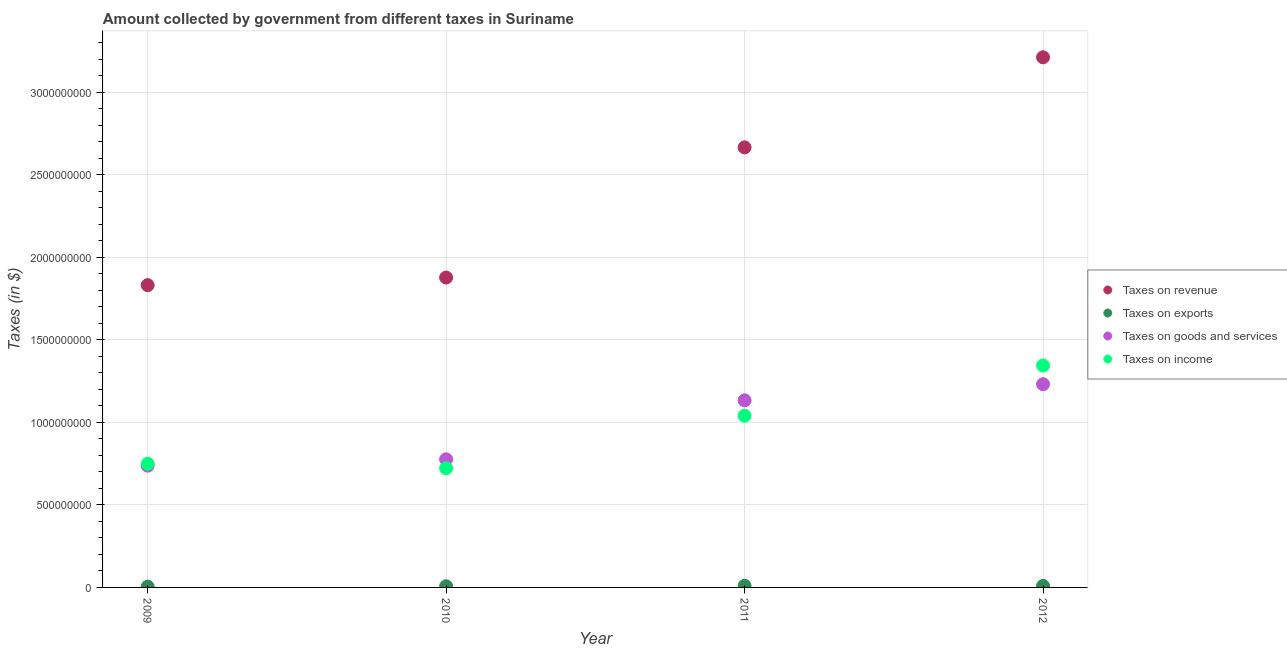What is the amount collected as tax on goods in 2009?
Give a very brief answer. 7.38e+08. Across all years, what is the maximum amount collected as tax on income?
Provide a short and direct response. 1.34e+09. Across all years, what is the minimum amount collected as tax on exports?
Provide a short and direct response. 4.27e+06. What is the total amount collected as tax on income in the graph?
Provide a succinct answer. 3.86e+09. What is the difference between the amount collected as tax on goods in 2009 and that in 2011?
Your answer should be compact. -3.96e+08. What is the difference between the amount collected as tax on goods in 2011 and the amount collected as tax on income in 2012?
Your response must be concise. -2.11e+08. What is the average amount collected as tax on revenue per year?
Your response must be concise. 2.40e+09. In the year 2012, what is the difference between the amount collected as tax on income and amount collected as tax on revenue?
Your answer should be compact. -1.87e+09. What is the ratio of the amount collected as tax on goods in 2009 to that in 2010?
Offer a very short reply. 0.95. Is the difference between the amount collected as tax on goods in 2011 and 2012 greater than the difference between the amount collected as tax on revenue in 2011 and 2012?
Provide a short and direct response. Yes. What is the difference between the highest and the second highest amount collected as tax on income?
Provide a succinct answer. 3.04e+08. What is the difference between the highest and the lowest amount collected as tax on income?
Ensure brevity in your answer.  6.23e+08. In how many years, is the amount collected as tax on income greater than the average amount collected as tax on income taken over all years?
Make the answer very short. 2. Is the sum of the amount collected as tax on revenue in 2010 and 2011 greater than the maximum amount collected as tax on income across all years?
Make the answer very short. Yes. Is it the case that in every year, the sum of the amount collected as tax on revenue and amount collected as tax on exports is greater than the sum of amount collected as tax on goods and amount collected as tax on income?
Your response must be concise. No. Is it the case that in every year, the sum of the amount collected as tax on revenue and amount collected as tax on exports is greater than the amount collected as tax on goods?
Your answer should be very brief. Yes. Does the amount collected as tax on goods monotonically increase over the years?
Provide a succinct answer. Yes. Is the amount collected as tax on income strictly greater than the amount collected as tax on goods over the years?
Ensure brevity in your answer.  No. How many dotlines are there?
Give a very brief answer. 4. How many years are there in the graph?
Keep it short and to the point. 4. What is the difference between two consecutive major ticks on the Y-axis?
Provide a succinct answer. 5.00e+08. Does the graph contain any zero values?
Your answer should be compact. No. Does the graph contain grids?
Your response must be concise. Yes. How are the legend labels stacked?
Keep it short and to the point. Vertical. What is the title of the graph?
Your response must be concise. Amount collected by government from different taxes in Suriname. Does "Finland" appear as one of the legend labels in the graph?
Your response must be concise. No. What is the label or title of the X-axis?
Provide a short and direct response. Year. What is the label or title of the Y-axis?
Provide a succinct answer. Taxes (in $). What is the Taxes (in $) in Taxes on revenue in 2009?
Offer a terse response. 1.83e+09. What is the Taxes (in $) of Taxes on exports in 2009?
Ensure brevity in your answer.  4.27e+06. What is the Taxes (in $) in Taxes on goods and services in 2009?
Offer a terse response. 7.38e+08. What is the Taxes (in $) of Taxes on income in 2009?
Ensure brevity in your answer.  7.49e+08. What is the Taxes (in $) of Taxes on revenue in 2010?
Your answer should be compact. 1.88e+09. What is the Taxes (in $) in Taxes on exports in 2010?
Keep it short and to the point. 7.16e+06. What is the Taxes (in $) in Taxes on goods and services in 2010?
Provide a succinct answer. 7.76e+08. What is the Taxes (in $) of Taxes on income in 2010?
Give a very brief answer. 7.22e+08. What is the Taxes (in $) in Taxes on revenue in 2011?
Provide a short and direct response. 2.67e+09. What is the Taxes (in $) in Taxes on exports in 2011?
Your answer should be very brief. 9.93e+06. What is the Taxes (in $) in Taxes on goods and services in 2011?
Your response must be concise. 1.13e+09. What is the Taxes (in $) in Taxes on income in 2011?
Ensure brevity in your answer.  1.04e+09. What is the Taxes (in $) of Taxes on revenue in 2012?
Keep it short and to the point. 3.21e+09. What is the Taxes (in $) in Taxes on exports in 2012?
Make the answer very short. 9.10e+06. What is the Taxes (in $) of Taxes on goods and services in 2012?
Ensure brevity in your answer.  1.23e+09. What is the Taxes (in $) of Taxes on income in 2012?
Provide a succinct answer. 1.34e+09. Across all years, what is the maximum Taxes (in $) in Taxes on revenue?
Ensure brevity in your answer.  3.21e+09. Across all years, what is the maximum Taxes (in $) of Taxes on exports?
Provide a short and direct response. 9.93e+06. Across all years, what is the maximum Taxes (in $) in Taxes on goods and services?
Offer a very short reply. 1.23e+09. Across all years, what is the maximum Taxes (in $) in Taxes on income?
Your response must be concise. 1.34e+09. Across all years, what is the minimum Taxes (in $) in Taxes on revenue?
Offer a very short reply. 1.83e+09. Across all years, what is the minimum Taxes (in $) in Taxes on exports?
Your response must be concise. 4.27e+06. Across all years, what is the minimum Taxes (in $) in Taxes on goods and services?
Give a very brief answer. 7.38e+08. Across all years, what is the minimum Taxes (in $) of Taxes on income?
Keep it short and to the point. 7.22e+08. What is the total Taxes (in $) of Taxes on revenue in the graph?
Make the answer very short. 9.59e+09. What is the total Taxes (in $) of Taxes on exports in the graph?
Make the answer very short. 3.05e+07. What is the total Taxes (in $) in Taxes on goods and services in the graph?
Provide a succinct answer. 3.88e+09. What is the total Taxes (in $) in Taxes on income in the graph?
Give a very brief answer. 3.86e+09. What is the difference between the Taxes (in $) in Taxes on revenue in 2009 and that in 2010?
Your answer should be very brief. -4.60e+07. What is the difference between the Taxes (in $) of Taxes on exports in 2009 and that in 2010?
Offer a very short reply. -2.89e+06. What is the difference between the Taxes (in $) in Taxes on goods and services in 2009 and that in 2010?
Provide a succinct answer. -3.87e+07. What is the difference between the Taxes (in $) of Taxes on income in 2009 and that in 2010?
Make the answer very short. 2.70e+07. What is the difference between the Taxes (in $) of Taxes on revenue in 2009 and that in 2011?
Give a very brief answer. -8.35e+08. What is the difference between the Taxes (in $) of Taxes on exports in 2009 and that in 2011?
Make the answer very short. -5.66e+06. What is the difference between the Taxes (in $) of Taxes on goods and services in 2009 and that in 2011?
Keep it short and to the point. -3.96e+08. What is the difference between the Taxes (in $) of Taxes on income in 2009 and that in 2011?
Offer a very short reply. -2.91e+08. What is the difference between the Taxes (in $) in Taxes on revenue in 2009 and that in 2012?
Provide a short and direct response. -1.38e+09. What is the difference between the Taxes (in $) in Taxes on exports in 2009 and that in 2012?
Offer a very short reply. -4.83e+06. What is the difference between the Taxes (in $) in Taxes on goods and services in 2009 and that in 2012?
Keep it short and to the point. -4.94e+08. What is the difference between the Taxes (in $) in Taxes on income in 2009 and that in 2012?
Your response must be concise. -5.95e+08. What is the difference between the Taxes (in $) in Taxes on revenue in 2010 and that in 2011?
Ensure brevity in your answer.  -7.89e+08. What is the difference between the Taxes (in $) in Taxes on exports in 2010 and that in 2011?
Ensure brevity in your answer.  -2.77e+06. What is the difference between the Taxes (in $) of Taxes on goods and services in 2010 and that in 2011?
Provide a succinct answer. -3.57e+08. What is the difference between the Taxes (in $) of Taxes on income in 2010 and that in 2011?
Your answer should be very brief. -3.18e+08. What is the difference between the Taxes (in $) in Taxes on revenue in 2010 and that in 2012?
Offer a terse response. -1.33e+09. What is the difference between the Taxes (in $) of Taxes on exports in 2010 and that in 2012?
Your answer should be compact. -1.94e+06. What is the difference between the Taxes (in $) of Taxes on goods and services in 2010 and that in 2012?
Make the answer very short. -4.55e+08. What is the difference between the Taxes (in $) of Taxes on income in 2010 and that in 2012?
Provide a succinct answer. -6.23e+08. What is the difference between the Taxes (in $) in Taxes on revenue in 2011 and that in 2012?
Keep it short and to the point. -5.46e+08. What is the difference between the Taxes (in $) of Taxes on exports in 2011 and that in 2012?
Your answer should be compact. 8.28e+05. What is the difference between the Taxes (in $) in Taxes on goods and services in 2011 and that in 2012?
Your response must be concise. -9.76e+07. What is the difference between the Taxes (in $) of Taxes on income in 2011 and that in 2012?
Make the answer very short. -3.04e+08. What is the difference between the Taxes (in $) in Taxes on revenue in 2009 and the Taxes (in $) in Taxes on exports in 2010?
Provide a succinct answer. 1.82e+09. What is the difference between the Taxes (in $) of Taxes on revenue in 2009 and the Taxes (in $) of Taxes on goods and services in 2010?
Make the answer very short. 1.06e+09. What is the difference between the Taxes (in $) in Taxes on revenue in 2009 and the Taxes (in $) in Taxes on income in 2010?
Keep it short and to the point. 1.11e+09. What is the difference between the Taxes (in $) in Taxes on exports in 2009 and the Taxes (in $) in Taxes on goods and services in 2010?
Make the answer very short. -7.72e+08. What is the difference between the Taxes (in $) of Taxes on exports in 2009 and the Taxes (in $) of Taxes on income in 2010?
Keep it short and to the point. -7.18e+08. What is the difference between the Taxes (in $) of Taxes on goods and services in 2009 and the Taxes (in $) of Taxes on income in 2010?
Your answer should be compact. 1.53e+07. What is the difference between the Taxes (in $) in Taxes on revenue in 2009 and the Taxes (in $) in Taxes on exports in 2011?
Offer a terse response. 1.82e+09. What is the difference between the Taxes (in $) in Taxes on revenue in 2009 and the Taxes (in $) in Taxes on goods and services in 2011?
Offer a very short reply. 6.98e+08. What is the difference between the Taxes (in $) of Taxes on revenue in 2009 and the Taxes (in $) of Taxes on income in 2011?
Ensure brevity in your answer.  7.91e+08. What is the difference between the Taxes (in $) in Taxes on exports in 2009 and the Taxes (in $) in Taxes on goods and services in 2011?
Provide a succinct answer. -1.13e+09. What is the difference between the Taxes (in $) of Taxes on exports in 2009 and the Taxes (in $) of Taxes on income in 2011?
Ensure brevity in your answer.  -1.04e+09. What is the difference between the Taxes (in $) in Taxes on goods and services in 2009 and the Taxes (in $) in Taxes on income in 2011?
Provide a succinct answer. -3.03e+08. What is the difference between the Taxes (in $) in Taxes on revenue in 2009 and the Taxes (in $) in Taxes on exports in 2012?
Provide a succinct answer. 1.82e+09. What is the difference between the Taxes (in $) of Taxes on revenue in 2009 and the Taxes (in $) of Taxes on goods and services in 2012?
Your answer should be compact. 6.00e+08. What is the difference between the Taxes (in $) in Taxes on revenue in 2009 and the Taxes (in $) in Taxes on income in 2012?
Your answer should be very brief. 4.87e+08. What is the difference between the Taxes (in $) in Taxes on exports in 2009 and the Taxes (in $) in Taxes on goods and services in 2012?
Make the answer very short. -1.23e+09. What is the difference between the Taxes (in $) in Taxes on exports in 2009 and the Taxes (in $) in Taxes on income in 2012?
Provide a short and direct response. -1.34e+09. What is the difference between the Taxes (in $) in Taxes on goods and services in 2009 and the Taxes (in $) in Taxes on income in 2012?
Provide a succinct answer. -6.07e+08. What is the difference between the Taxes (in $) of Taxes on revenue in 2010 and the Taxes (in $) of Taxes on exports in 2011?
Provide a short and direct response. 1.87e+09. What is the difference between the Taxes (in $) in Taxes on revenue in 2010 and the Taxes (in $) in Taxes on goods and services in 2011?
Give a very brief answer. 7.44e+08. What is the difference between the Taxes (in $) of Taxes on revenue in 2010 and the Taxes (in $) of Taxes on income in 2011?
Ensure brevity in your answer.  8.37e+08. What is the difference between the Taxes (in $) in Taxes on exports in 2010 and the Taxes (in $) in Taxes on goods and services in 2011?
Make the answer very short. -1.13e+09. What is the difference between the Taxes (in $) in Taxes on exports in 2010 and the Taxes (in $) in Taxes on income in 2011?
Ensure brevity in your answer.  -1.03e+09. What is the difference between the Taxes (in $) of Taxes on goods and services in 2010 and the Taxes (in $) of Taxes on income in 2011?
Keep it short and to the point. -2.64e+08. What is the difference between the Taxes (in $) in Taxes on revenue in 2010 and the Taxes (in $) in Taxes on exports in 2012?
Ensure brevity in your answer.  1.87e+09. What is the difference between the Taxes (in $) of Taxes on revenue in 2010 and the Taxes (in $) of Taxes on goods and services in 2012?
Give a very brief answer. 6.46e+08. What is the difference between the Taxes (in $) in Taxes on revenue in 2010 and the Taxes (in $) in Taxes on income in 2012?
Provide a short and direct response. 5.33e+08. What is the difference between the Taxes (in $) of Taxes on exports in 2010 and the Taxes (in $) of Taxes on goods and services in 2012?
Provide a succinct answer. -1.22e+09. What is the difference between the Taxes (in $) of Taxes on exports in 2010 and the Taxes (in $) of Taxes on income in 2012?
Offer a terse response. -1.34e+09. What is the difference between the Taxes (in $) in Taxes on goods and services in 2010 and the Taxes (in $) in Taxes on income in 2012?
Offer a terse response. -5.68e+08. What is the difference between the Taxes (in $) of Taxes on revenue in 2011 and the Taxes (in $) of Taxes on exports in 2012?
Keep it short and to the point. 2.66e+09. What is the difference between the Taxes (in $) in Taxes on revenue in 2011 and the Taxes (in $) in Taxes on goods and services in 2012?
Your answer should be very brief. 1.44e+09. What is the difference between the Taxes (in $) of Taxes on revenue in 2011 and the Taxes (in $) of Taxes on income in 2012?
Offer a very short reply. 1.32e+09. What is the difference between the Taxes (in $) in Taxes on exports in 2011 and the Taxes (in $) in Taxes on goods and services in 2012?
Your answer should be compact. -1.22e+09. What is the difference between the Taxes (in $) in Taxes on exports in 2011 and the Taxes (in $) in Taxes on income in 2012?
Make the answer very short. -1.33e+09. What is the difference between the Taxes (in $) of Taxes on goods and services in 2011 and the Taxes (in $) of Taxes on income in 2012?
Offer a terse response. -2.11e+08. What is the average Taxes (in $) in Taxes on revenue per year?
Offer a terse response. 2.40e+09. What is the average Taxes (in $) in Taxes on exports per year?
Your answer should be compact. 7.62e+06. What is the average Taxes (in $) in Taxes on goods and services per year?
Keep it short and to the point. 9.70e+08. What is the average Taxes (in $) of Taxes on income per year?
Offer a terse response. 9.64e+08. In the year 2009, what is the difference between the Taxes (in $) in Taxes on revenue and Taxes (in $) in Taxes on exports?
Provide a short and direct response. 1.83e+09. In the year 2009, what is the difference between the Taxes (in $) of Taxes on revenue and Taxes (in $) of Taxes on goods and services?
Ensure brevity in your answer.  1.09e+09. In the year 2009, what is the difference between the Taxes (in $) of Taxes on revenue and Taxes (in $) of Taxes on income?
Keep it short and to the point. 1.08e+09. In the year 2009, what is the difference between the Taxes (in $) of Taxes on exports and Taxes (in $) of Taxes on goods and services?
Ensure brevity in your answer.  -7.33e+08. In the year 2009, what is the difference between the Taxes (in $) of Taxes on exports and Taxes (in $) of Taxes on income?
Provide a succinct answer. -7.45e+08. In the year 2009, what is the difference between the Taxes (in $) of Taxes on goods and services and Taxes (in $) of Taxes on income?
Make the answer very short. -1.17e+07. In the year 2010, what is the difference between the Taxes (in $) of Taxes on revenue and Taxes (in $) of Taxes on exports?
Provide a short and direct response. 1.87e+09. In the year 2010, what is the difference between the Taxes (in $) of Taxes on revenue and Taxes (in $) of Taxes on goods and services?
Your answer should be very brief. 1.10e+09. In the year 2010, what is the difference between the Taxes (in $) in Taxes on revenue and Taxes (in $) in Taxes on income?
Give a very brief answer. 1.16e+09. In the year 2010, what is the difference between the Taxes (in $) in Taxes on exports and Taxes (in $) in Taxes on goods and services?
Your answer should be compact. -7.69e+08. In the year 2010, what is the difference between the Taxes (in $) in Taxes on exports and Taxes (in $) in Taxes on income?
Offer a terse response. -7.15e+08. In the year 2010, what is the difference between the Taxes (in $) of Taxes on goods and services and Taxes (in $) of Taxes on income?
Your answer should be very brief. 5.40e+07. In the year 2011, what is the difference between the Taxes (in $) in Taxes on revenue and Taxes (in $) in Taxes on exports?
Offer a terse response. 2.66e+09. In the year 2011, what is the difference between the Taxes (in $) of Taxes on revenue and Taxes (in $) of Taxes on goods and services?
Ensure brevity in your answer.  1.53e+09. In the year 2011, what is the difference between the Taxes (in $) in Taxes on revenue and Taxes (in $) in Taxes on income?
Keep it short and to the point. 1.63e+09. In the year 2011, what is the difference between the Taxes (in $) in Taxes on exports and Taxes (in $) in Taxes on goods and services?
Offer a very short reply. -1.12e+09. In the year 2011, what is the difference between the Taxes (in $) of Taxes on exports and Taxes (in $) of Taxes on income?
Your answer should be compact. -1.03e+09. In the year 2011, what is the difference between the Taxes (in $) of Taxes on goods and services and Taxes (in $) of Taxes on income?
Offer a terse response. 9.34e+07. In the year 2012, what is the difference between the Taxes (in $) in Taxes on revenue and Taxes (in $) in Taxes on exports?
Give a very brief answer. 3.20e+09. In the year 2012, what is the difference between the Taxes (in $) of Taxes on revenue and Taxes (in $) of Taxes on goods and services?
Make the answer very short. 1.98e+09. In the year 2012, what is the difference between the Taxes (in $) of Taxes on revenue and Taxes (in $) of Taxes on income?
Make the answer very short. 1.87e+09. In the year 2012, what is the difference between the Taxes (in $) in Taxes on exports and Taxes (in $) in Taxes on goods and services?
Offer a terse response. -1.22e+09. In the year 2012, what is the difference between the Taxes (in $) in Taxes on exports and Taxes (in $) in Taxes on income?
Provide a succinct answer. -1.34e+09. In the year 2012, what is the difference between the Taxes (in $) in Taxes on goods and services and Taxes (in $) in Taxes on income?
Keep it short and to the point. -1.13e+08. What is the ratio of the Taxes (in $) of Taxes on revenue in 2009 to that in 2010?
Make the answer very short. 0.98. What is the ratio of the Taxes (in $) in Taxes on exports in 2009 to that in 2010?
Provide a succinct answer. 0.6. What is the ratio of the Taxes (in $) in Taxes on goods and services in 2009 to that in 2010?
Offer a very short reply. 0.95. What is the ratio of the Taxes (in $) of Taxes on income in 2009 to that in 2010?
Offer a terse response. 1.04. What is the ratio of the Taxes (in $) of Taxes on revenue in 2009 to that in 2011?
Your response must be concise. 0.69. What is the ratio of the Taxes (in $) of Taxes on exports in 2009 to that in 2011?
Ensure brevity in your answer.  0.43. What is the ratio of the Taxes (in $) in Taxes on goods and services in 2009 to that in 2011?
Provide a short and direct response. 0.65. What is the ratio of the Taxes (in $) of Taxes on income in 2009 to that in 2011?
Give a very brief answer. 0.72. What is the ratio of the Taxes (in $) of Taxes on revenue in 2009 to that in 2012?
Your answer should be compact. 0.57. What is the ratio of the Taxes (in $) of Taxes on exports in 2009 to that in 2012?
Offer a very short reply. 0.47. What is the ratio of the Taxes (in $) in Taxes on goods and services in 2009 to that in 2012?
Your answer should be compact. 0.6. What is the ratio of the Taxes (in $) in Taxes on income in 2009 to that in 2012?
Your answer should be compact. 0.56. What is the ratio of the Taxes (in $) in Taxes on revenue in 2010 to that in 2011?
Keep it short and to the point. 0.7. What is the ratio of the Taxes (in $) of Taxes on exports in 2010 to that in 2011?
Your answer should be compact. 0.72. What is the ratio of the Taxes (in $) in Taxes on goods and services in 2010 to that in 2011?
Offer a terse response. 0.68. What is the ratio of the Taxes (in $) in Taxes on income in 2010 to that in 2011?
Provide a short and direct response. 0.69. What is the ratio of the Taxes (in $) in Taxes on revenue in 2010 to that in 2012?
Keep it short and to the point. 0.58. What is the ratio of the Taxes (in $) in Taxes on exports in 2010 to that in 2012?
Your answer should be very brief. 0.79. What is the ratio of the Taxes (in $) of Taxes on goods and services in 2010 to that in 2012?
Make the answer very short. 0.63. What is the ratio of the Taxes (in $) in Taxes on income in 2010 to that in 2012?
Your answer should be very brief. 0.54. What is the ratio of the Taxes (in $) in Taxes on revenue in 2011 to that in 2012?
Your answer should be very brief. 0.83. What is the ratio of the Taxes (in $) of Taxes on exports in 2011 to that in 2012?
Your answer should be very brief. 1.09. What is the ratio of the Taxes (in $) of Taxes on goods and services in 2011 to that in 2012?
Offer a very short reply. 0.92. What is the ratio of the Taxes (in $) of Taxes on income in 2011 to that in 2012?
Keep it short and to the point. 0.77. What is the difference between the highest and the second highest Taxes (in $) of Taxes on revenue?
Ensure brevity in your answer.  5.46e+08. What is the difference between the highest and the second highest Taxes (in $) in Taxes on exports?
Your response must be concise. 8.28e+05. What is the difference between the highest and the second highest Taxes (in $) of Taxes on goods and services?
Your response must be concise. 9.76e+07. What is the difference between the highest and the second highest Taxes (in $) in Taxes on income?
Provide a succinct answer. 3.04e+08. What is the difference between the highest and the lowest Taxes (in $) of Taxes on revenue?
Your answer should be compact. 1.38e+09. What is the difference between the highest and the lowest Taxes (in $) of Taxes on exports?
Provide a short and direct response. 5.66e+06. What is the difference between the highest and the lowest Taxes (in $) in Taxes on goods and services?
Provide a short and direct response. 4.94e+08. What is the difference between the highest and the lowest Taxes (in $) in Taxes on income?
Provide a succinct answer. 6.23e+08. 